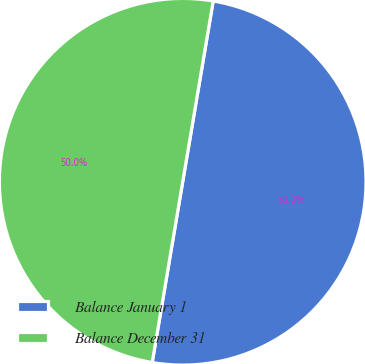<chart> <loc_0><loc_0><loc_500><loc_500><pie_chart><fcel>Balance January 1<fcel>Balance December 31<nl><fcel>50.0%<fcel>50.0%<nl></chart> 